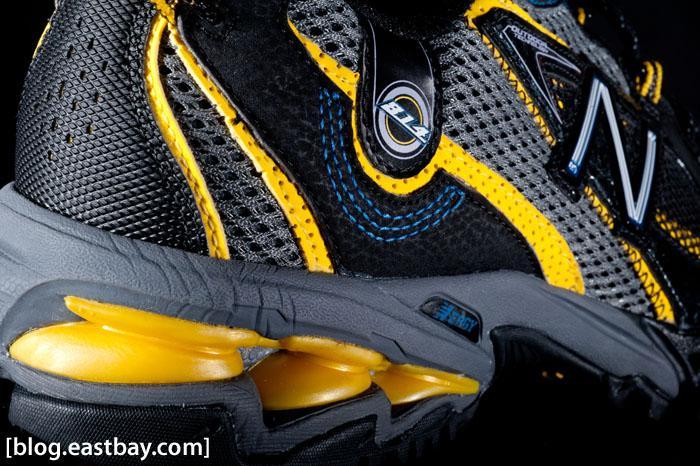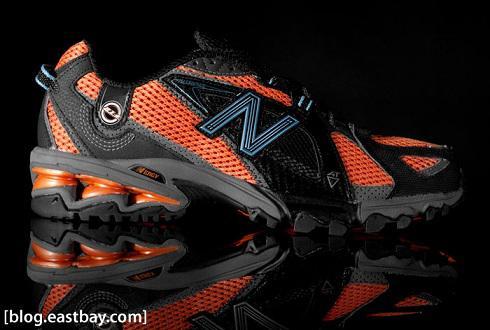The first image is the image on the left, the second image is the image on the right. Assess this claim about the two images: "There are fewer than four shoes in total.". Correct or not? Answer yes or no. Yes. The first image is the image on the left, the second image is the image on the right. Assess this claim about the two images: "There are more shoes in the image on the right.". Correct or not? Answer yes or no. No. 